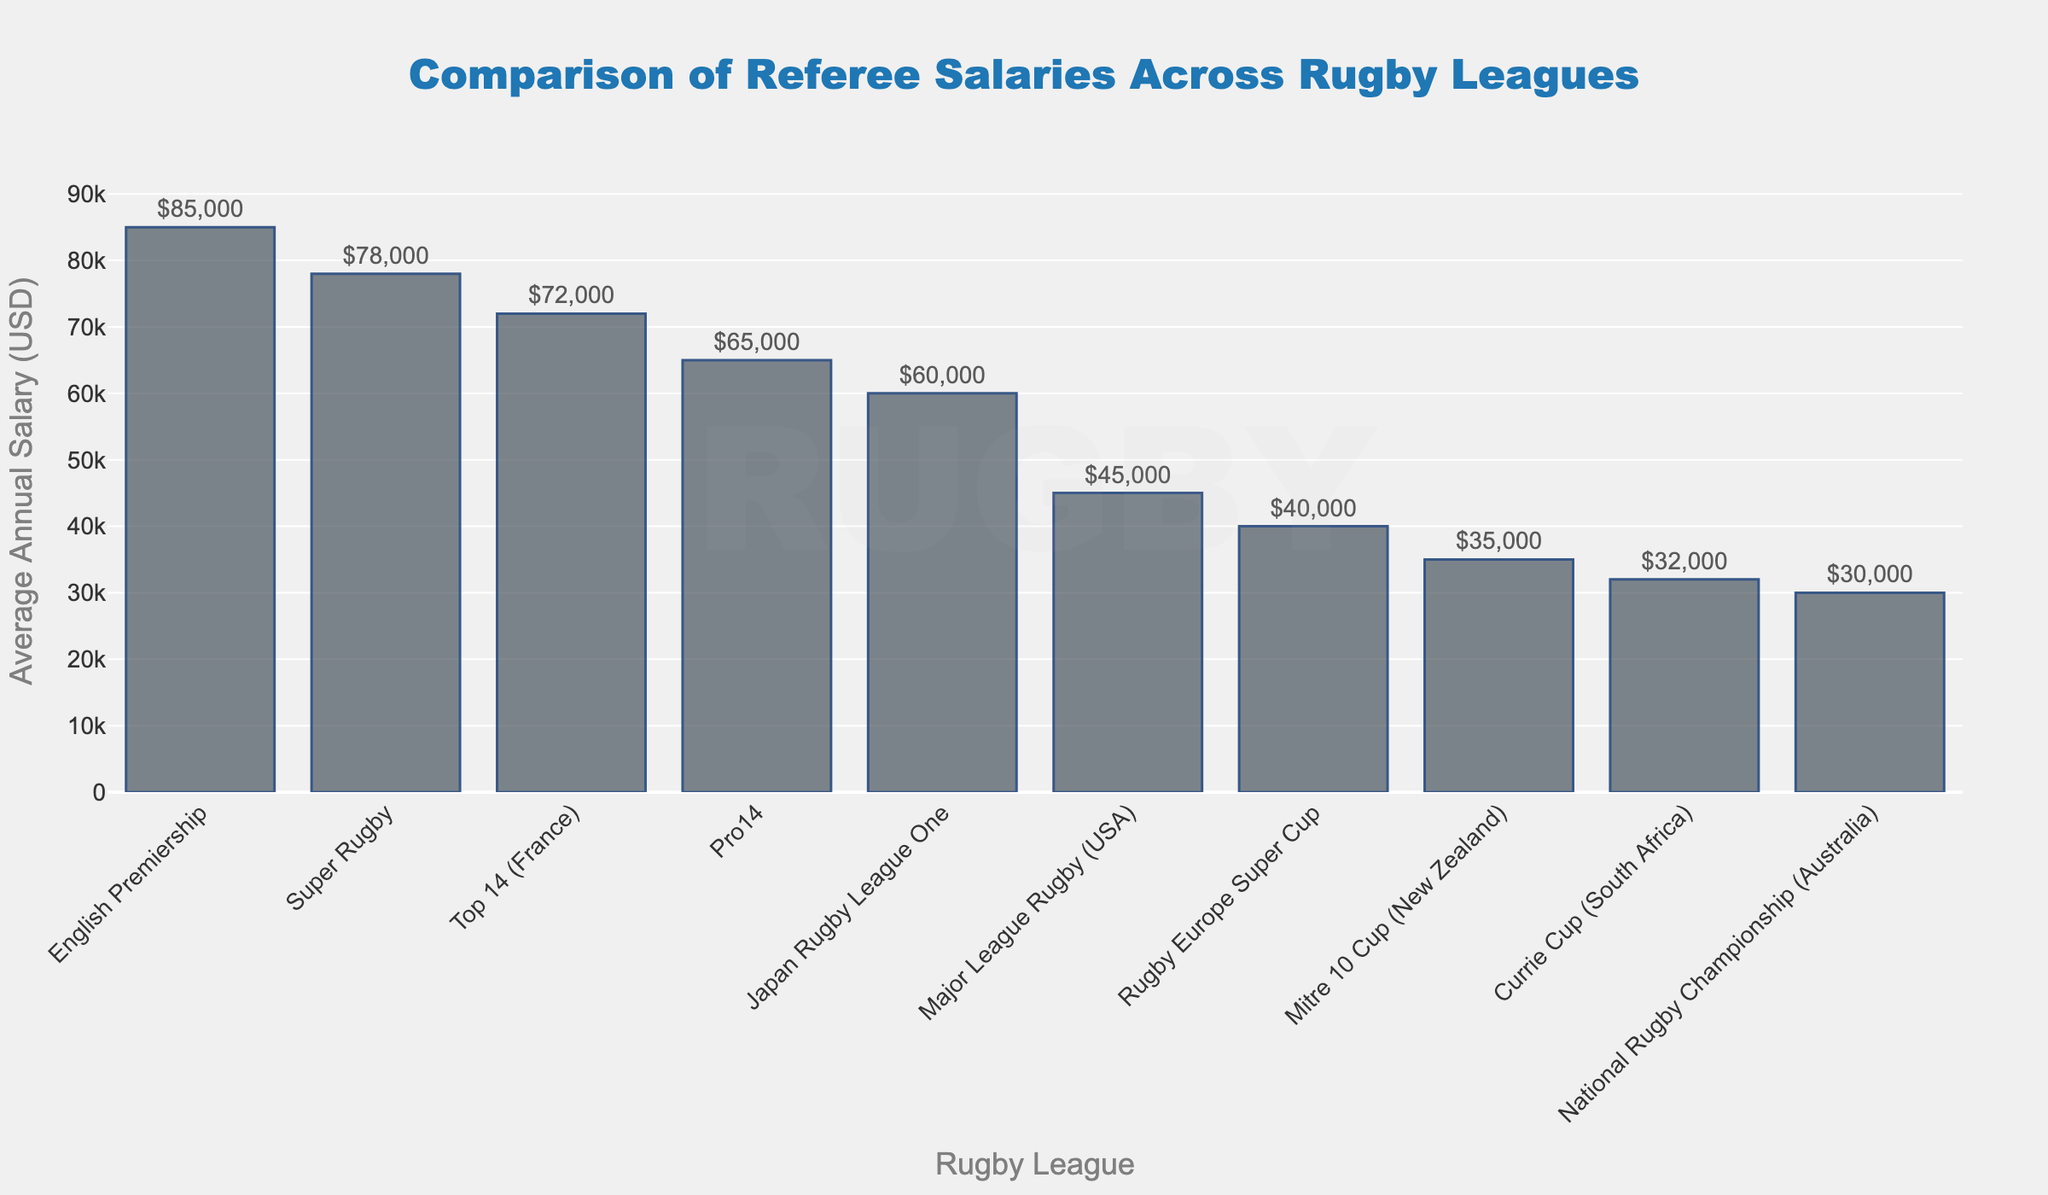Which league has the highest average annual salary for referees? The bar representing the "English Premiership" is the tallest among all bars in the chart, indicating it has the highest value.
Answer: English Premiership What is the difference in average annual salary between the Major League Rugby (USA) and the National Rugby Championship (Australia)? The bar for Major League Rugby (USA) shows an average annual salary of $45,000, and the bar for National Rugby Championship (Australia) shows $30,000. The difference is $45,000 - $30,000 = $15,000.
Answer: $15,000 How much more do referees in the English Premiership earn compared to those in the Top 14 (France)? The bar for the English Premiership is at $85,000 and the bar for Top 14 (France) is at $72,000. The difference is $85,000 - $72,000 = $13,000.
Answer: $13,000 Which league has the lowest average annual salary, and what is that salary? The shortest bar in the chart represents the "National Rugby Championship (Australia)", indicating it has the lowest value. The salary is shown at $30,000.
Answer: National Rugby Championship (Australia), $30,000 What is the average salary of referees in the Pro14 and Japan Rugby League One? The bar for Pro14 shows $65,000, and the bar for Japan Rugby League One shows $60,000. The average is ($65,000 + $60,000) / 2 = $62,500.
Answer: $62,500 How many leagues have an average annual salary less than $50,000? The bars for Major League Rugby (USA), Rugby Europe Super Cup, Mitre 10 Cup (New Zealand), Currie Cup (South Africa), and National Rugby Championship (Australia) are below $50,000. Therefore, there are 5 leagues.
Answer: 5 Which has a higher average annual salary: Super Rugby or Top 14 (France)? The bar for Super Rugby shows $78,000, while the bar for Top 14 (France) shows $72,000. The Super Rugby has a higher value.
Answer: Super Rugby By how much does the average salary for referees in the Rugby Europe Super Cup differ from referees in the Currie Cup (South Africa)? The bar for Rugby Europe Super Cup shows $40,000, and the bar for Currie Cup (South Africa) shows $32,000. The difference is $40,000 - $32,000 = $8,000.
Answer: $8,000 What is the total combined average annual salary for referees in the Super Rugby and English Premiership leagues? The bar for Super Rugby shows $78,000, and the bar for the English Premiership shows $85,000. The combined total is $78,000 + $85,000 = $163,000.
Answer: $163,000 Which league has a closer average annual salary to Major League Rugby (USA), Mitre 10 Cup (New Zealand) or Rugby Europe Super Cup? The bar for Major League Rugby (USA) is at $45,000, the bar for Mitre 10 Cup (New Zealand) is at $35,000, and the bar for Rugby Europe Super Cup is at $40,000. The difference for Mitre 10 Cup is $45,000 - $35,000 = $10,000. The difference for Rugby Europe Super Cup is $45,000 - $40,000 = $5,000. Rugby Europe Super Cup is closer.
Answer: Rugby Europe Super Cup 